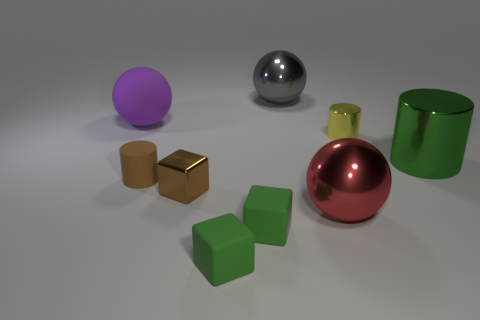Subtract all large metallic balls. How many balls are left? 1 Subtract all gray cylinders. How many green cubes are left? 2 Subtract 1 cubes. How many cubes are left? 2 Subtract all balls. How many objects are left? 6 Add 1 small green metal cubes. How many objects exist? 10 Add 3 large green rubber cylinders. How many large green rubber cylinders exist? 3 Subtract 0 red cubes. How many objects are left? 9 Subtract all tiny yellow cylinders. Subtract all big gray metallic balls. How many objects are left? 7 Add 8 rubber cylinders. How many rubber cylinders are left? 9 